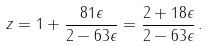<formula> <loc_0><loc_0><loc_500><loc_500>z = 1 + \frac { 8 1 \epsilon } { 2 - 6 3 \epsilon } = \frac { 2 + 1 8 \epsilon } { 2 - 6 3 \epsilon } \, .</formula> 